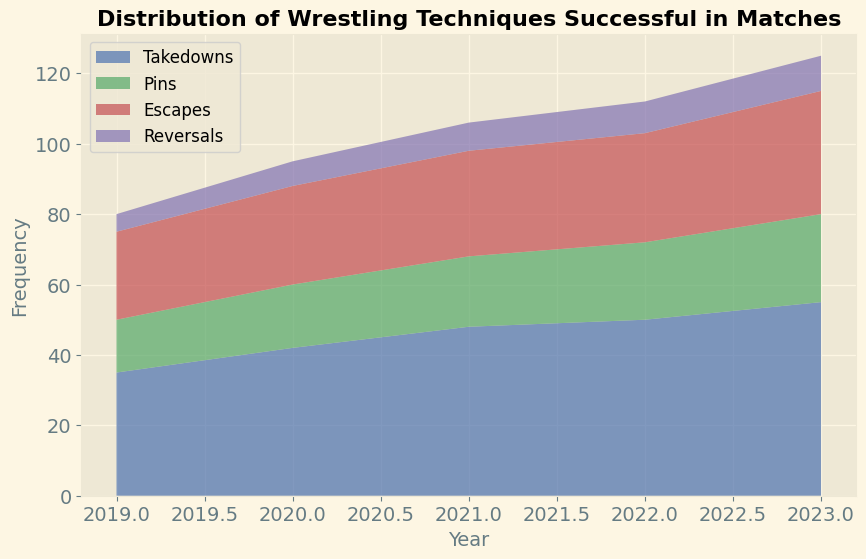What is the overall trend in the frequency of Takedowns from 2019 to 2023? The area chart shows an increasing trend in the frequency of Takedowns, with the values rising each year from 2019 to 2023. In 2019, the frequency of Takedowns was 35, and by 2023, it increased to 55.
Answer: Increasing In which year was the frequency of Pins the highest? By examining the heights of the area representing Pins in the chart, you can see that the frequency of Pins was highest in 2023.
Answer: 2023 How does the frequency of Escapes in 2022 compare to that in 2019? By comparing the height of the Escapes area for the years 2022 and 2019, you can see that the frequency of Escapes in 2022 is higher than in 2019. The values are 31 in 2022 compared to 25 in 2019.
Answer: Higher in 2022 What is the sum of the frequencies of Reversals from 2019 to 2023? Adding up the frequencies of Reversals for each year (5 in 2019, 7 in 2020, 8 in 2021, 9 in 2022, and 10 in 2023): 5 + 7 + 8 + 9 + 10 = 39.
Answer: 39 Which technique shows the most significant increase in frequency from 2019 to 2023? By observing the chart, Takedowns show the most significant increase from 35 in 2019 to 55 in 2023. None of the other techniques shows as large an increase.
Answer: Takedowns How many techniques have higher frequencies in 2022 than in 2020? By comparing the frequencies of all techniques in 2022 with those in 2020:
- Takedowns (50 vs. 42) ⇒ Higher in 2022
- Pins (22 vs. 18) ⇒ Higher in 2022
- Escapes (31 vs. 28) ⇒ Higher in 2022
- Reversals (9 vs. 7) ⇒ Higher in 2022
All four techniques have higher frequencies in 2022.
Answer: 4 Which technique remained consistently lower in frequency compared to the other techniques? By looking at the relative height of the areas in the chart, Reversals remained consistently lower in frequency compared to Takedowns, Pins, and Escapes throughout the years.
Answer: Reversals What is the average frequency of Pins across all years from 2019 to 2023? Calculate the sum of Pins frequencies and divide by the number of years: (15 + 18 + 20 + 22 + 25) / 5 = 100 / 5 = 20.
Answer: 20 What is the difference in frequency between Takedowns and Escapes in 2023? Subtract the frequency of Escapes from the frequency of Takedowns in 2023: 55 (Takedowns) - 35 (Escapes) = 20.
Answer: 20 During which year did the sum of the frequencies for all techniques reach the highest value? Summing the frequencies for all techniques for each year:
2019: 35 (Takedowns) + 15 (Pins) + 25 (Escapes) + 5 (Reversals) = 80
2020: 42 (Takedowns) + 18 (Pins) + 28 (Escapes) + 7 (Reversals) = 95
2021: 48 (Takedowns) + 20 (Pins) + 30 (Escapes) + 8 (Reversals) = 106
2022: 50 (Takedowns) + 22 (Pins) + 31 (Escapes) + 9 (Reversals) = 112
2023: 55 (Takedowns) + 25 (Pins) + 35 (Escapes) + 10 (Reversals) = 125
The year with the highest sum is 2023.
Answer: 2023 